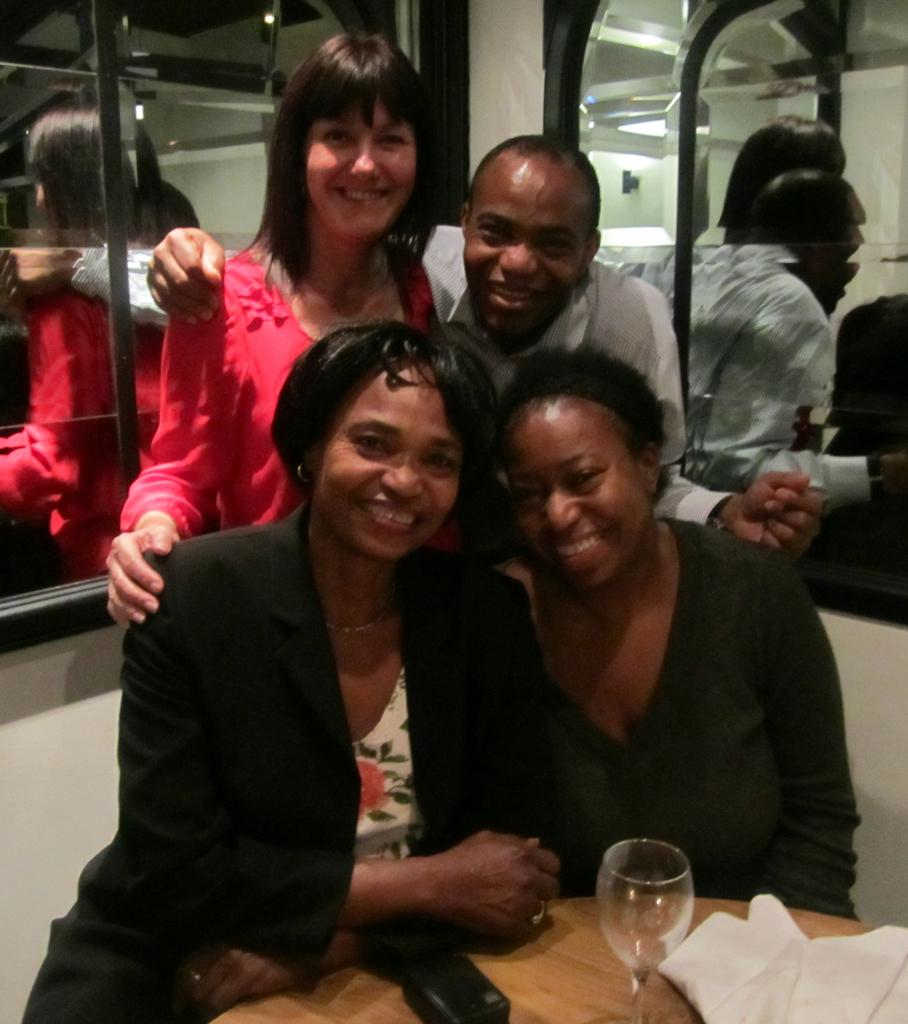What are the women in the image doing? The two women are sitting on a table in the image. What are the people behind the table doing? There are two people standing behind the table in the image. What can be seen in the background of the image? There is a mirror in the background of the image. What year is depicted in the mirror in the image? The image does not show a reflection in the mirror, so it is not possible to determine the year. How many ducks are visible in the image? There are no ducks present in the image. 